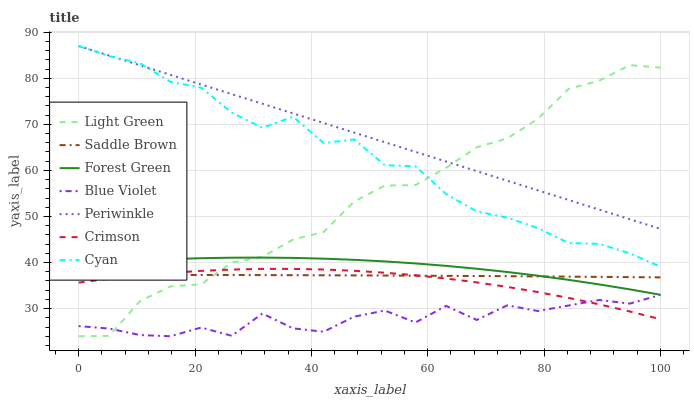Does Blue Violet have the minimum area under the curve?
Answer yes or no. Yes. Does Periwinkle have the maximum area under the curve?
Answer yes or no. Yes. Does Light Green have the minimum area under the curve?
Answer yes or no. No. Does Light Green have the maximum area under the curve?
Answer yes or no. No. Is Periwinkle the smoothest?
Answer yes or no. Yes. Is Blue Violet the roughest?
Answer yes or no. Yes. Is Light Green the smoothest?
Answer yes or no. No. Is Light Green the roughest?
Answer yes or no. No. Does Light Green have the lowest value?
Answer yes or no. Yes. Does Periwinkle have the lowest value?
Answer yes or no. No. Does Cyan have the highest value?
Answer yes or no. Yes. Does Light Green have the highest value?
Answer yes or no. No. Is Crimson less than Forest Green?
Answer yes or no. Yes. Is Cyan greater than Saddle Brown?
Answer yes or no. Yes. Does Forest Green intersect Light Green?
Answer yes or no. Yes. Is Forest Green less than Light Green?
Answer yes or no. No. Is Forest Green greater than Light Green?
Answer yes or no. No. Does Crimson intersect Forest Green?
Answer yes or no. No. 